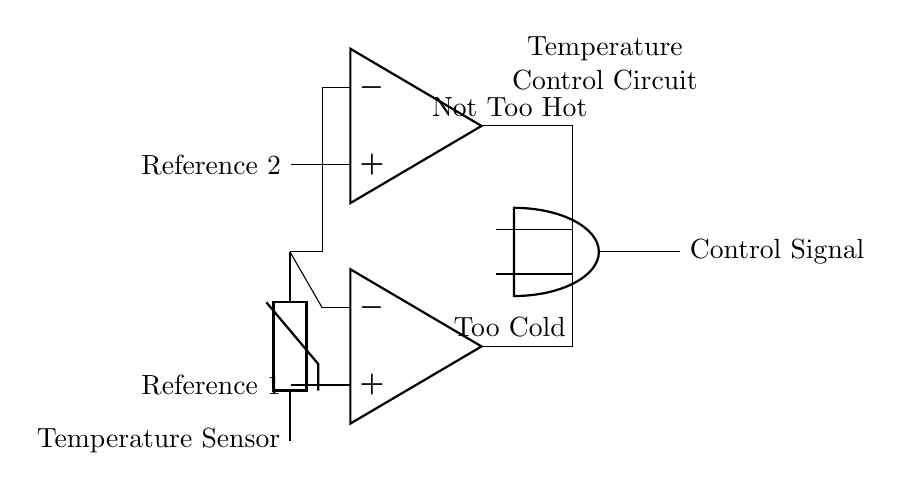What type of sensors are used in the circuit? The circuit utilizes a temperature sensor, specifically a thermistor, which is indicated at the beginning of the diagram.
Answer: Thermistor What do the two comparators check in this circuit? The first comparator checks if the temperature is too cold, while the second checks if it is not too hot. This is indicated by the labels "Too Cold" and "Not Too Hot" connected to each comparator’s output.
Answer: Temperature conditions What does the output control signal represent? The output control signal is the result of an AND operation on the outputs of the two comparators, indicating the combined condition of the temperature checks.
Answer: Control signal How many comparators are present in the circuit? There are two operational amplifiers functioning as comparators, which are clearly marked in the diagram.
Answer: Two What logic gate is used in this temperature control circuit? The circuit uses an AND gate, as labeled in the diagram, which combines the outputs of the two comparators to determine the control signal.
Answer: AND gate What would happen if either comparator output is low? If either comparator output is low, the AND gate will output a low signal, meaning that the conditions for temperature control are not met to maintain a suitable environment for the books. Thus, the system will not activate the control signal.
Answer: No control signal 